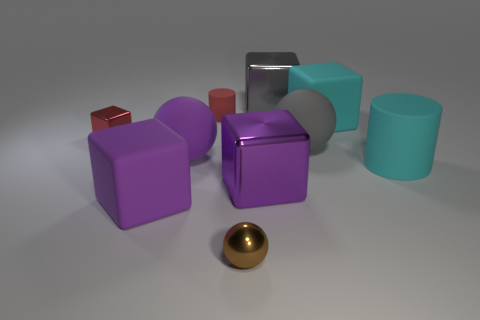Is there a reflection visible on any of the objects, and if so, can you describe it? Yes, the metallic ball and the chrome cube in the center showcase reflections. The ball reflects the environment with a distortion typical of spherical surfaces, whereas the cube reflects its surroundings with more geometric clarity. 